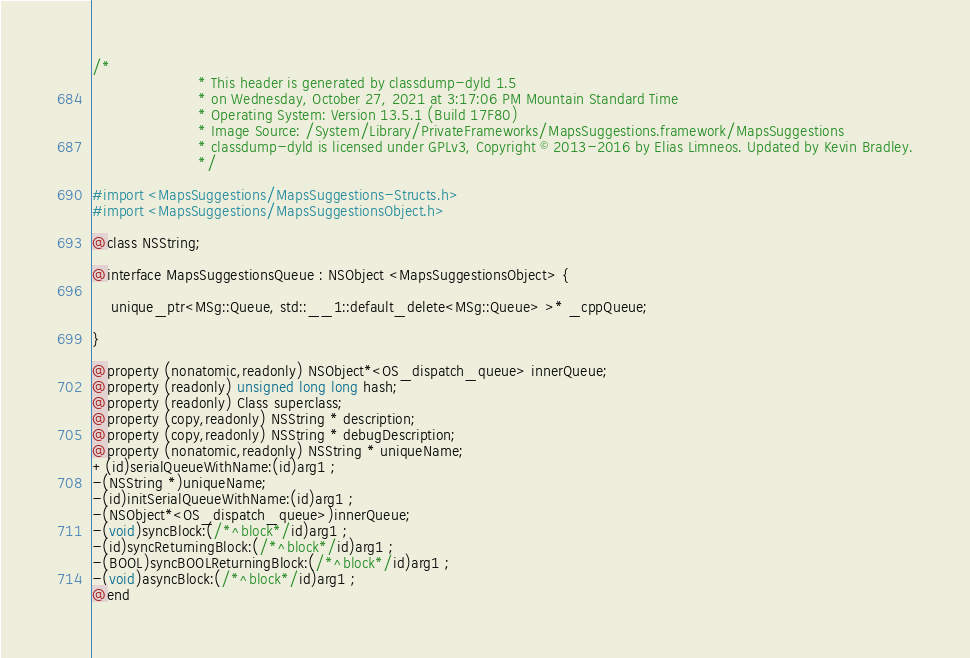<code> <loc_0><loc_0><loc_500><loc_500><_C_>/*
                       * This header is generated by classdump-dyld 1.5
                       * on Wednesday, October 27, 2021 at 3:17:06 PM Mountain Standard Time
                       * Operating System: Version 13.5.1 (Build 17F80)
                       * Image Source: /System/Library/PrivateFrameworks/MapsSuggestions.framework/MapsSuggestions
                       * classdump-dyld is licensed under GPLv3, Copyright © 2013-2016 by Elias Limneos. Updated by Kevin Bradley.
                       */

#import <MapsSuggestions/MapsSuggestions-Structs.h>
#import <MapsSuggestions/MapsSuggestionsObject.h>

@class NSString;

@interface MapsSuggestionsQueue : NSObject <MapsSuggestionsObject> {

	unique_ptr<MSg::Queue, std::__1::default_delete<MSg::Queue> >* _cppQueue;

}

@property (nonatomic,readonly) NSObject*<OS_dispatch_queue> innerQueue; 
@property (readonly) unsigned long long hash; 
@property (readonly) Class superclass; 
@property (copy,readonly) NSString * description; 
@property (copy,readonly) NSString * debugDescription; 
@property (nonatomic,readonly) NSString * uniqueName; 
+(id)serialQueueWithName:(id)arg1 ;
-(NSString *)uniqueName;
-(id)initSerialQueueWithName:(id)arg1 ;
-(NSObject*<OS_dispatch_queue>)innerQueue;
-(void)syncBlock:(/*^block*/id)arg1 ;
-(id)syncReturningBlock:(/*^block*/id)arg1 ;
-(BOOL)syncBOOLReturningBlock:(/*^block*/id)arg1 ;
-(void)asyncBlock:(/*^block*/id)arg1 ;
@end

</code> 